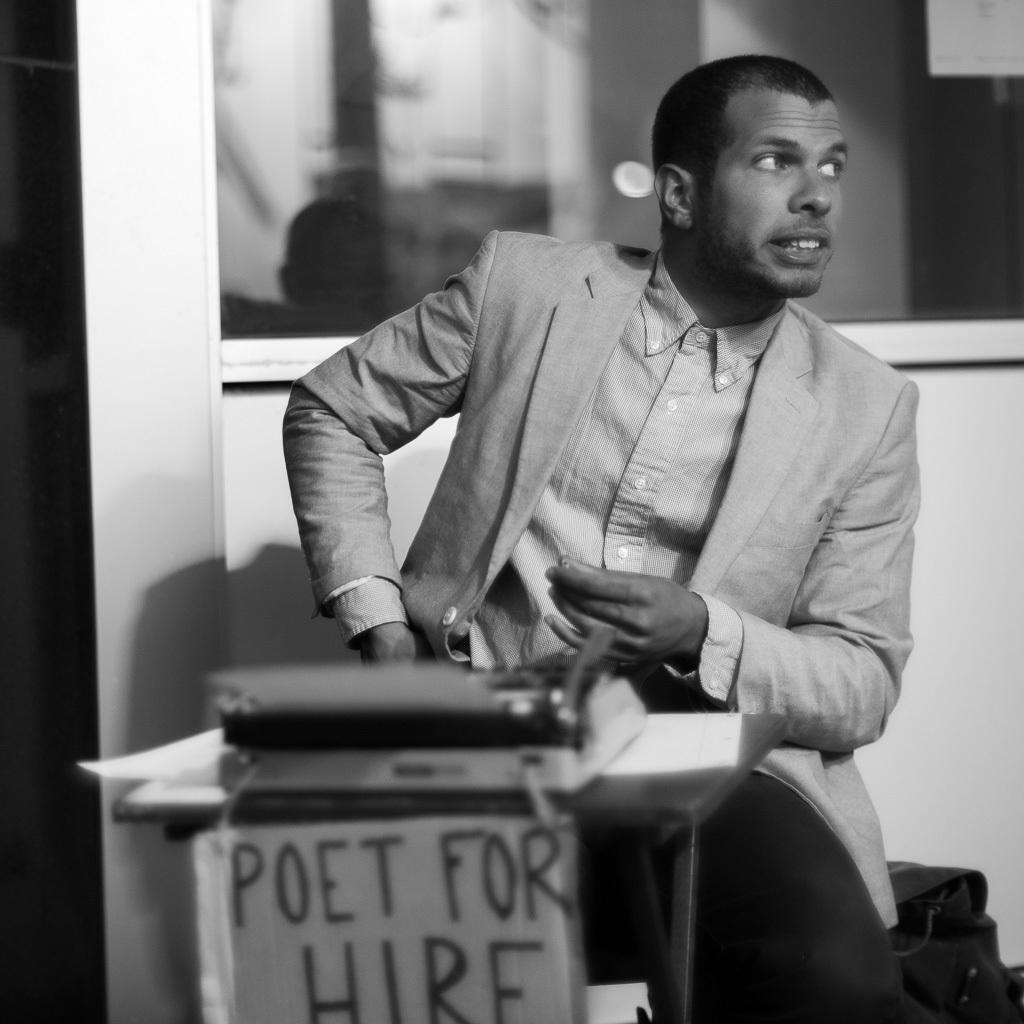Describe this image in one or two sentences. In this image, we can see a man sitting, he is wearing a coat, there is a table, on that table, we can see a book, in the background we can see the wall and a window. 